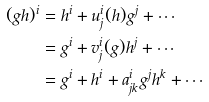Convert formula to latex. <formula><loc_0><loc_0><loc_500><loc_500>( g h ) ^ { i } & = h ^ { i } + u ^ { i } _ { j } ( h ) g ^ { j } + \cdots \\ & = g ^ { i } + v ^ { i } _ { j } ( g ) h ^ { j } + \cdots \\ & = g ^ { i } + h ^ { i } + a ^ { i } _ { j k } g ^ { j } h ^ { k } + \cdots</formula> 